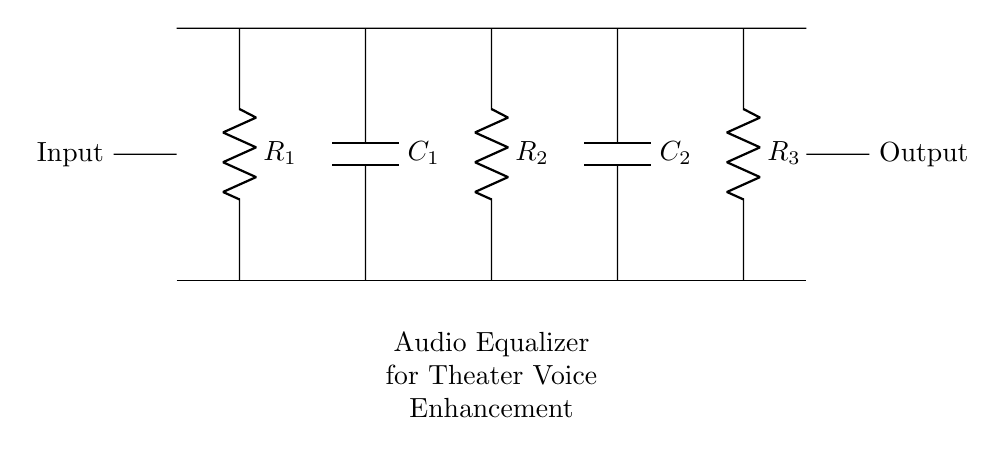What is the total number of resistors in the circuit? The circuit diagram shows three resistors labeled as R1, R2, and R3. We simply count the labeled components to find the total.
Answer: 3 What is the function of the capacitors in this circuit? Capacitors, labeled as C1 and C2, are used for frequency response shaping and filtering. They help in smoothing the audio signals for voice enhancement by influencing the transient response and frequency characteristics of the circuit.
Answer: Filtering What is the connection type for the input and output? The input and output are connected via short connections, indicated by the short lines to the left and right sides of the circuit diagram. This signifies direct connections to external audio sources and outputs without any additional components between them.
Answer: Short connections Which resistor is positioned between the two capacitors? R2 is placed between C1 and C2, directly connecting them in the circuit layout. To find it, we look at the arrangement of components and their labels.
Answer: R2 What type of circuit is represented in the diagram? The circuit is specifically an audio equalizer circuit, which combines resistors and capacitors to enhance vocal sound quality. This is determined from the overall label of the circuit which indicates its main application.
Answer: Audio equalizer What could happen if one capacitor is removed from the circuit? The removal of either capacitor (C1 or C2) would alter the frequency response of the circuit. We deduce this from their roles in shaping audio signals; removing one would likely degrade the overall voice enhancement feature, reducing effectiveness at certain frequencies.
Answer: Altered frequency response 